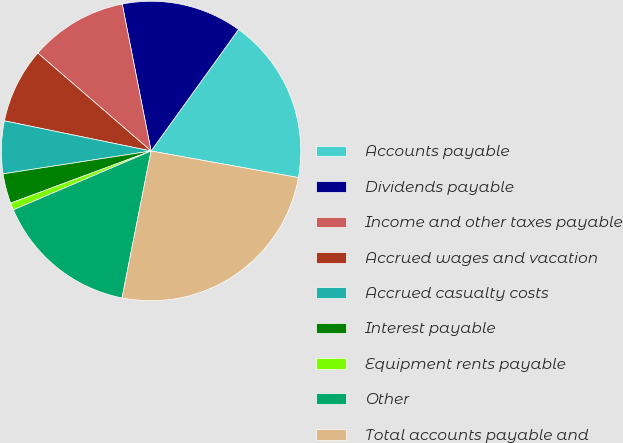<chart> <loc_0><loc_0><loc_500><loc_500><pie_chart><fcel>Accounts payable<fcel>Dividends payable<fcel>Income and other taxes payable<fcel>Accrued wages and vacation<fcel>Accrued casualty costs<fcel>Interest payable<fcel>Equipment rents payable<fcel>Other<fcel>Total accounts payable and<nl><fcel>17.92%<fcel>13.02%<fcel>10.57%<fcel>8.12%<fcel>5.67%<fcel>3.22%<fcel>0.77%<fcel>15.47%<fcel>25.27%<nl></chart> 